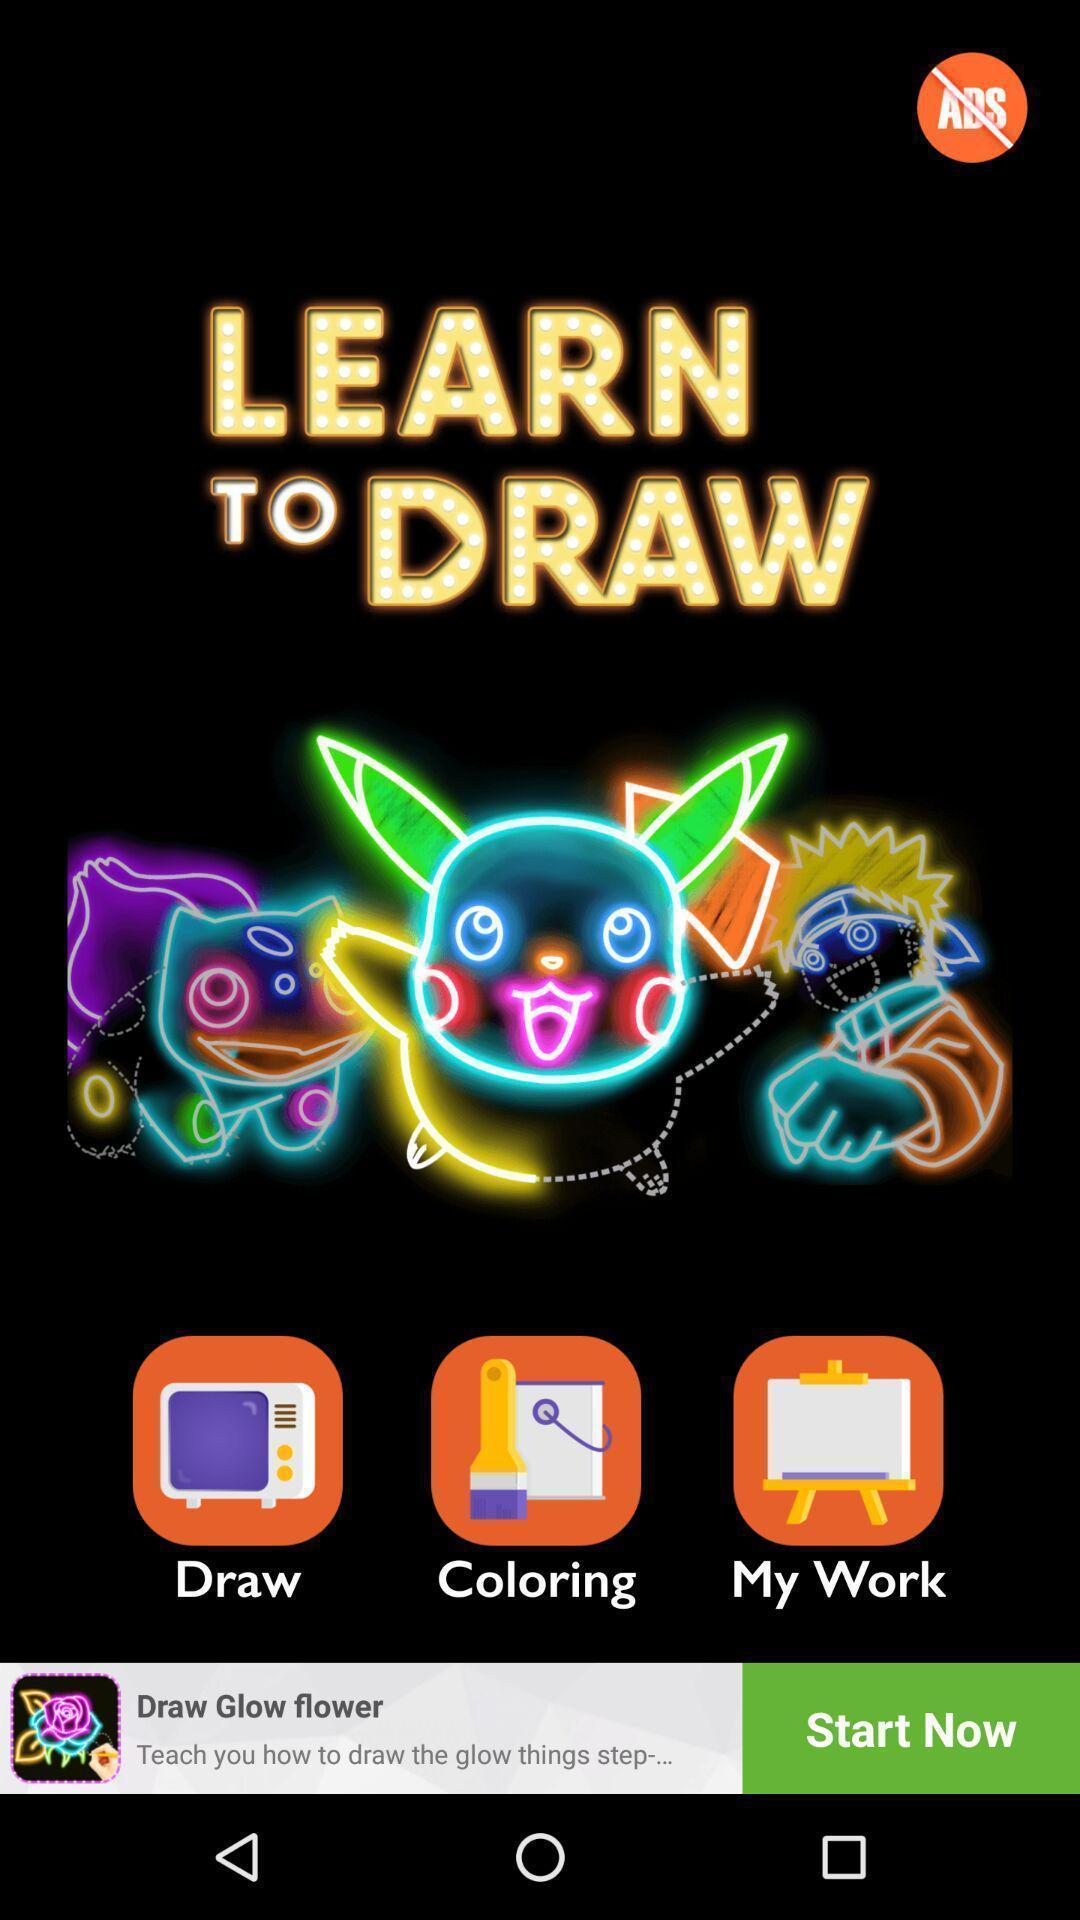Tell me about the visual elements in this screen capture. Welcome page of a drawing app. 